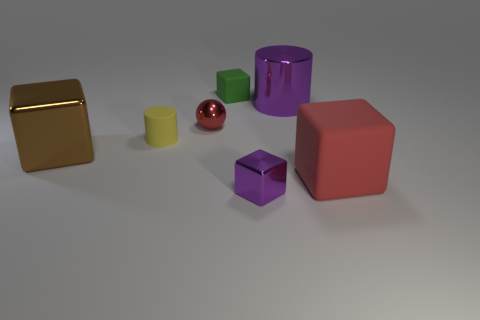What is the size of the metal cylinder that is the same color as the tiny metal cube?
Your answer should be compact. Large. Is there a cube behind the small cylinder behind the large brown metal cube?
Provide a short and direct response. Yes. What number of green shiny balls are there?
Offer a terse response. 0. There is a small ball; is its color the same as the rubber cube in front of the tiny red object?
Your answer should be very brief. Yes. Are there more red blocks than small gray balls?
Offer a very short reply. Yes. Is there anything else of the same color as the big cylinder?
Your response must be concise. Yes. How many other things are the same size as the red matte object?
Offer a very short reply. 2. There is a brown block that is left of the purple metal thing that is behind the tiny block that is in front of the tiny yellow thing; what is it made of?
Make the answer very short. Metal. Is the material of the small green block the same as the big cube to the right of the large purple thing?
Offer a very short reply. Yes. Is the number of big red things left of the large purple metal cylinder less than the number of rubber things to the left of the tiny red shiny thing?
Provide a short and direct response. Yes. 